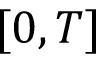Convert formula to latex. <formula><loc_0><loc_0><loc_500><loc_500>[ 0 , T ]</formula> 